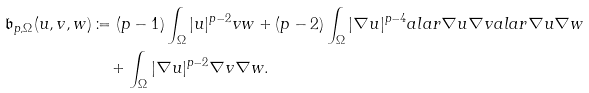<formula> <loc_0><loc_0><loc_500><loc_500>\mathfrak { b } _ { p , \Omega } ( u , v , w ) & \coloneqq ( p - 1 ) \int _ { \Omega } | u | ^ { p - 2 } v w + ( p - 2 ) \int _ { \Omega } | \nabla u | ^ { p - 4 } a l a r { \nabla u } { \nabla v } a l a r { \nabla u } { \nabla w } \\ & \quad + \int _ { \Omega } | \nabla u | ^ { p - 2 } \nabla v \nabla w .</formula> 